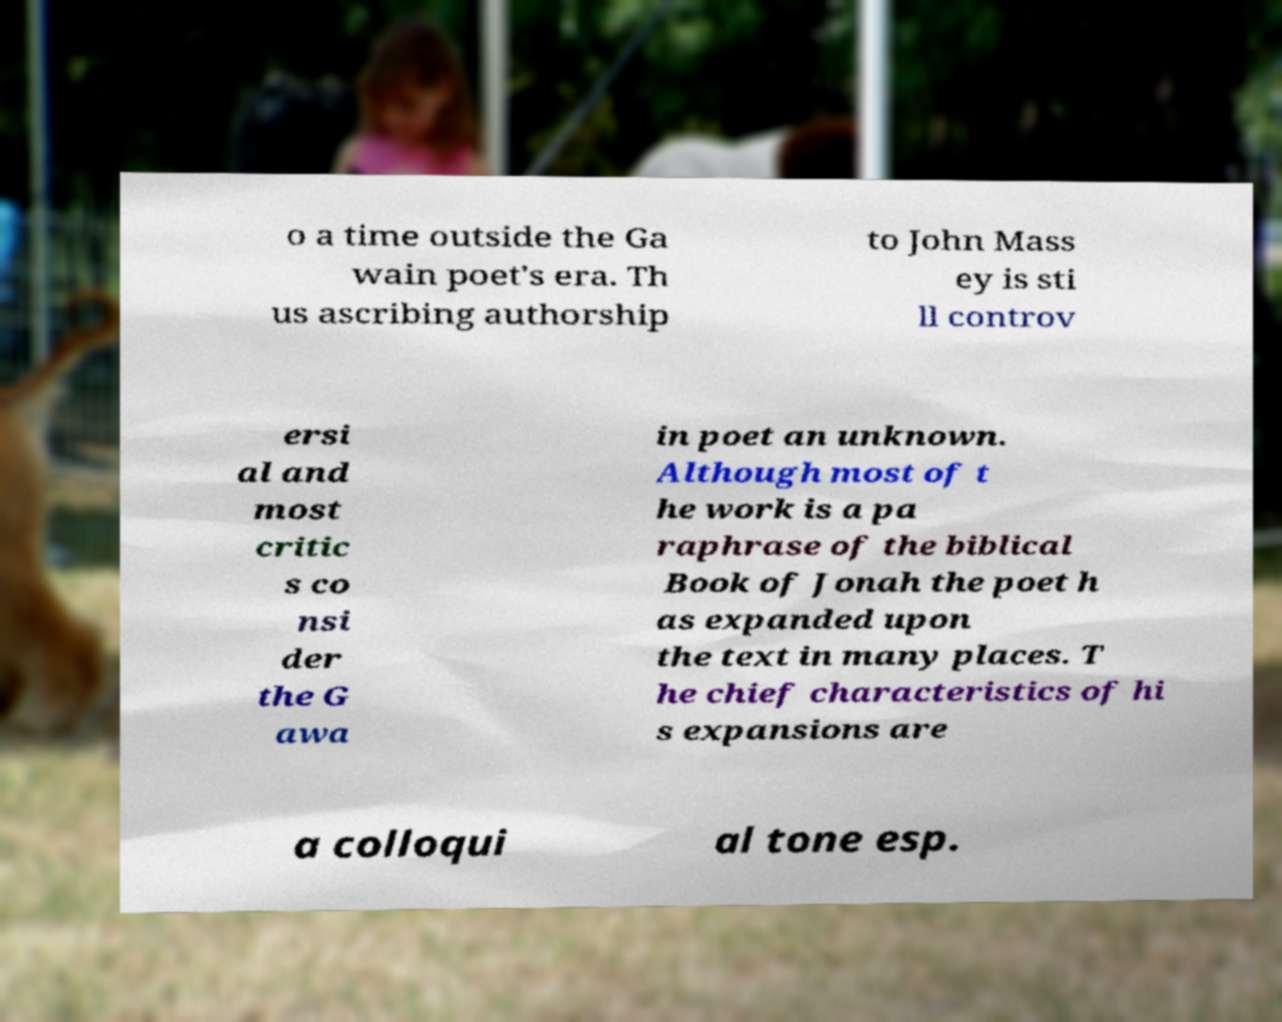Please identify and transcribe the text found in this image. o a time outside the Ga wain poet's era. Th us ascribing authorship to John Mass ey is sti ll controv ersi al and most critic s co nsi der the G awa in poet an unknown. Although most of t he work is a pa raphrase of the biblical Book of Jonah the poet h as expanded upon the text in many places. T he chief characteristics of hi s expansions are a colloqui al tone esp. 